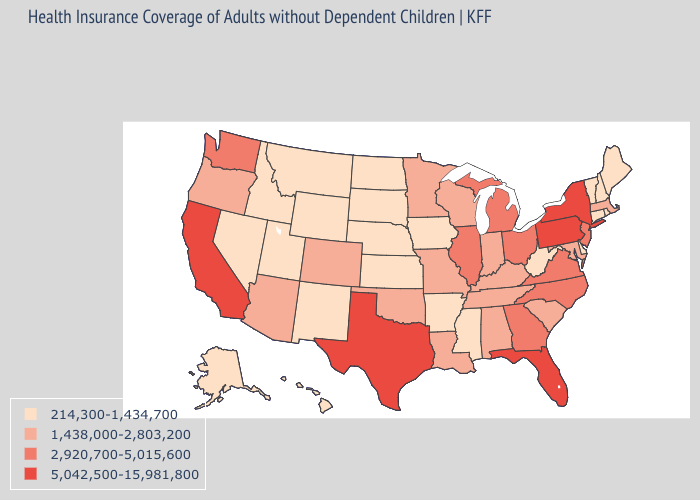Which states have the highest value in the USA?
Write a very short answer. California, Florida, New York, Pennsylvania, Texas. What is the lowest value in states that border Wyoming?
Be succinct. 214,300-1,434,700. What is the value of Pennsylvania?
Concise answer only. 5,042,500-15,981,800. Which states have the highest value in the USA?
Concise answer only. California, Florida, New York, Pennsylvania, Texas. Name the states that have a value in the range 214,300-1,434,700?
Quick response, please. Alaska, Arkansas, Connecticut, Delaware, Hawaii, Idaho, Iowa, Kansas, Maine, Mississippi, Montana, Nebraska, Nevada, New Hampshire, New Mexico, North Dakota, Rhode Island, South Dakota, Utah, Vermont, West Virginia, Wyoming. What is the value of Louisiana?
Quick response, please. 1,438,000-2,803,200. Among the states that border Alabama , does Georgia have the lowest value?
Keep it brief. No. What is the value of Massachusetts?
Keep it brief. 1,438,000-2,803,200. Name the states that have a value in the range 5,042,500-15,981,800?
Keep it brief. California, Florida, New York, Pennsylvania, Texas. What is the highest value in the South ?
Keep it brief. 5,042,500-15,981,800. Which states have the lowest value in the USA?
Keep it brief. Alaska, Arkansas, Connecticut, Delaware, Hawaii, Idaho, Iowa, Kansas, Maine, Mississippi, Montana, Nebraska, Nevada, New Hampshire, New Mexico, North Dakota, Rhode Island, South Dakota, Utah, Vermont, West Virginia, Wyoming. What is the highest value in the USA?
Quick response, please. 5,042,500-15,981,800. Which states have the highest value in the USA?
Concise answer only. California, Florida, New York, Pennsylvania, Texas. Among the states that border Mississippi , which have the lowest value?
Quick response, please. Arkansas. Does Texas have the highest value in the South?
Keep it brief. Yes. 